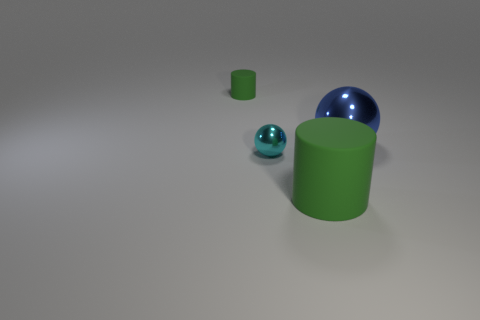Add 1 big cylinders. How many objects exist? 5 Add 2 big blue metal spheres. How many big blue metal spheres are left? 3 Add 4 big metallic objects. How many big metallic objects exist? 5 Subtract 0 yellow cylinders. How many objects are left? 4 Subtract all big cyan rubber objects. Subtract all small cyan shiny things. How many objects are left? 3 